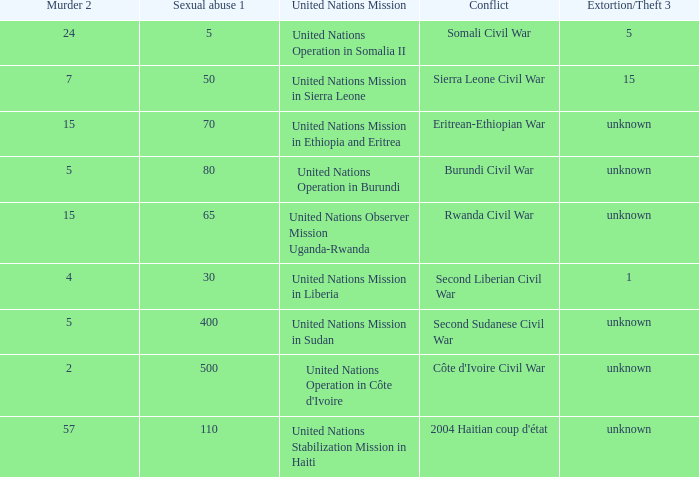What is the sexual abuse rate where the conflict is the Burundi Civil War? 80.0. 